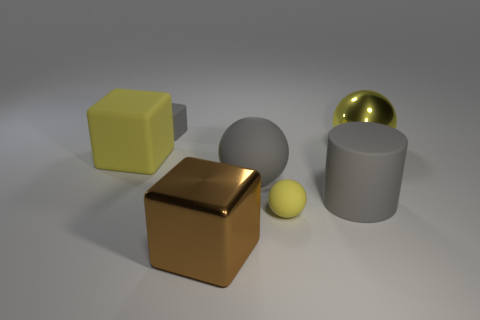The yellow matte thing that is the same shape as the large yellow metallic thing is what size?
Provide a succinct answer. Small. What color is the big sphere that is in front of the yellow shiny object?
Offer a terse response. Gray. What number of other objects are there of the same color as the small rubber sphere?
Your response must be concise. 2. Do the yellow thing on the left side of the brown metal cube and the large matte cylinder have the same size?
Your response must be concise. Yes. What number of large brown shiny blocks are to the right of the small yellow rubber thing?
Your answer should be compact. 0. Is there a gray thing that has the same size as the yellow matte block?
Your answer should be very brief. Yes. Is the color of the big cylinder the same as the tiny block?
Give a very brief answer. Yes. What color is the big shiny object to the left of the big sphere that is left of the large yellow metallic sphere?
Give a very brief answer. Brown. What number of yellow spheres are in front of the large rubber ball and behind the big yellow matte cube?
Provide a short and direct response. 0. What number of big yellow matte objects have the same shape as the brown metal thing?
Offer a terse response. 1. 